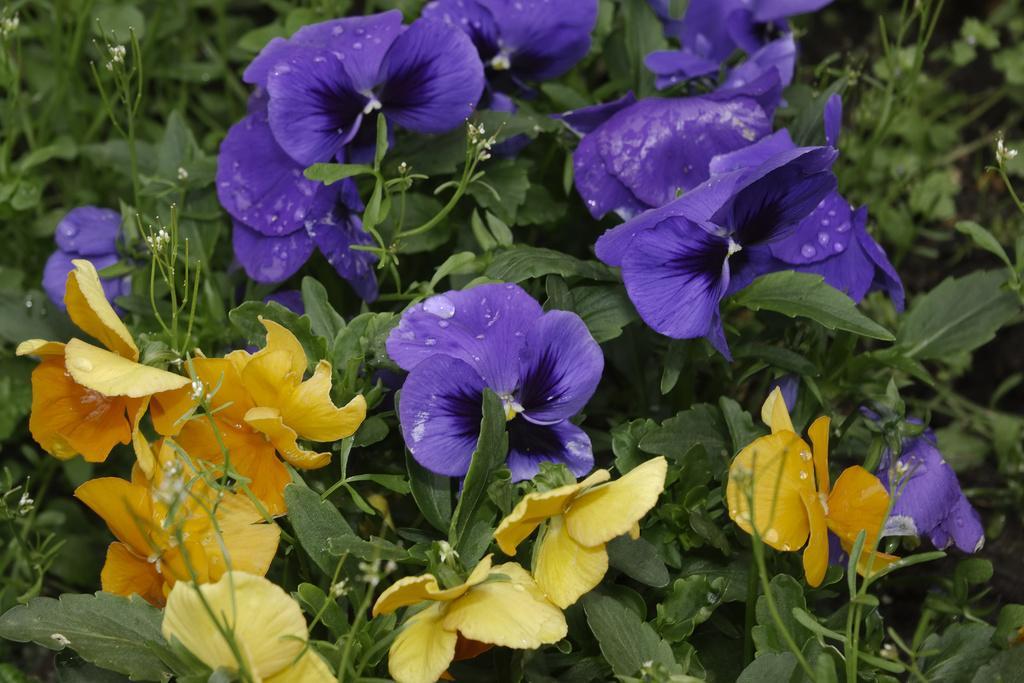Describe this image in one or two sentences. In this image there are plants. At the top there are violet flowers and at the bottom there are yellow flowers. 